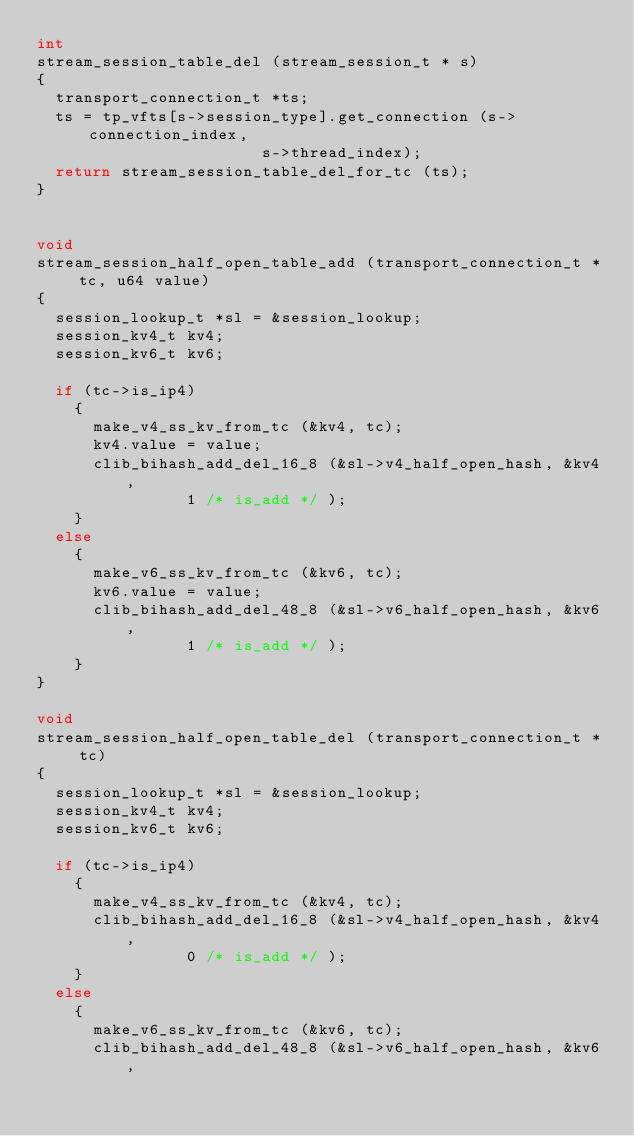<code> <loc_0><loc_0><loc_500><loc_500><_C_>int
stream_session_table_del (stream_session_t * s)
{
  transport_connection_t *ts;
  ts = tp_vfts[s->session_type].get_connection (s->connection_index,
						s->thread_index);
  return stream_session_table_del_for_tc (ts);
}


void
stream_session_half_open_table_add (transport_connection_t * tc, u64 value)
{
  session_lookup_t *sl = &session_lookup;
  session_kv4_t kv4;
  session_kv6_t kv6;

  if (tc->is_ip4)
    {
      make_v4_ss_kv_from_tc (&kv4, tc);
      kv4.value = value;
      clib_bihash_add_del_16_8 (&sl->v4_half_open_hash, &kv4,
				1 /* is_add */ );
    }
  else
    {
      make_v6_ss_kv_from_tc (&kv6, tc);
      kv6.value = value;
      clib_bihash_add_del_48_8 (&sl->v6_half_open_hash, &kv6,
				1 /* is_add */ );
    }
}

void
stream_session_half_open_table_del (transport_connection_t * tc)
{
  session_lookup_t *sl = &session_lookup;
  session_kv4_t kv4;
  session_kv6_t kv6;

  if (tc->is_ip4)
    {
      make_v4_ss_kv_from_tc (&kv4, tc);
      clib_bihash_add_del_16_8 (&sl->v4_half_open_hash, &kv4,
				0 /* is_add */ );
    }
  else
    {
      make_v6_ss_kv_from_tc (&kv6, tc);
      clib_bihash_add_del_48_8 (&sl->v6_half_open_hash, &kv6,</code> 